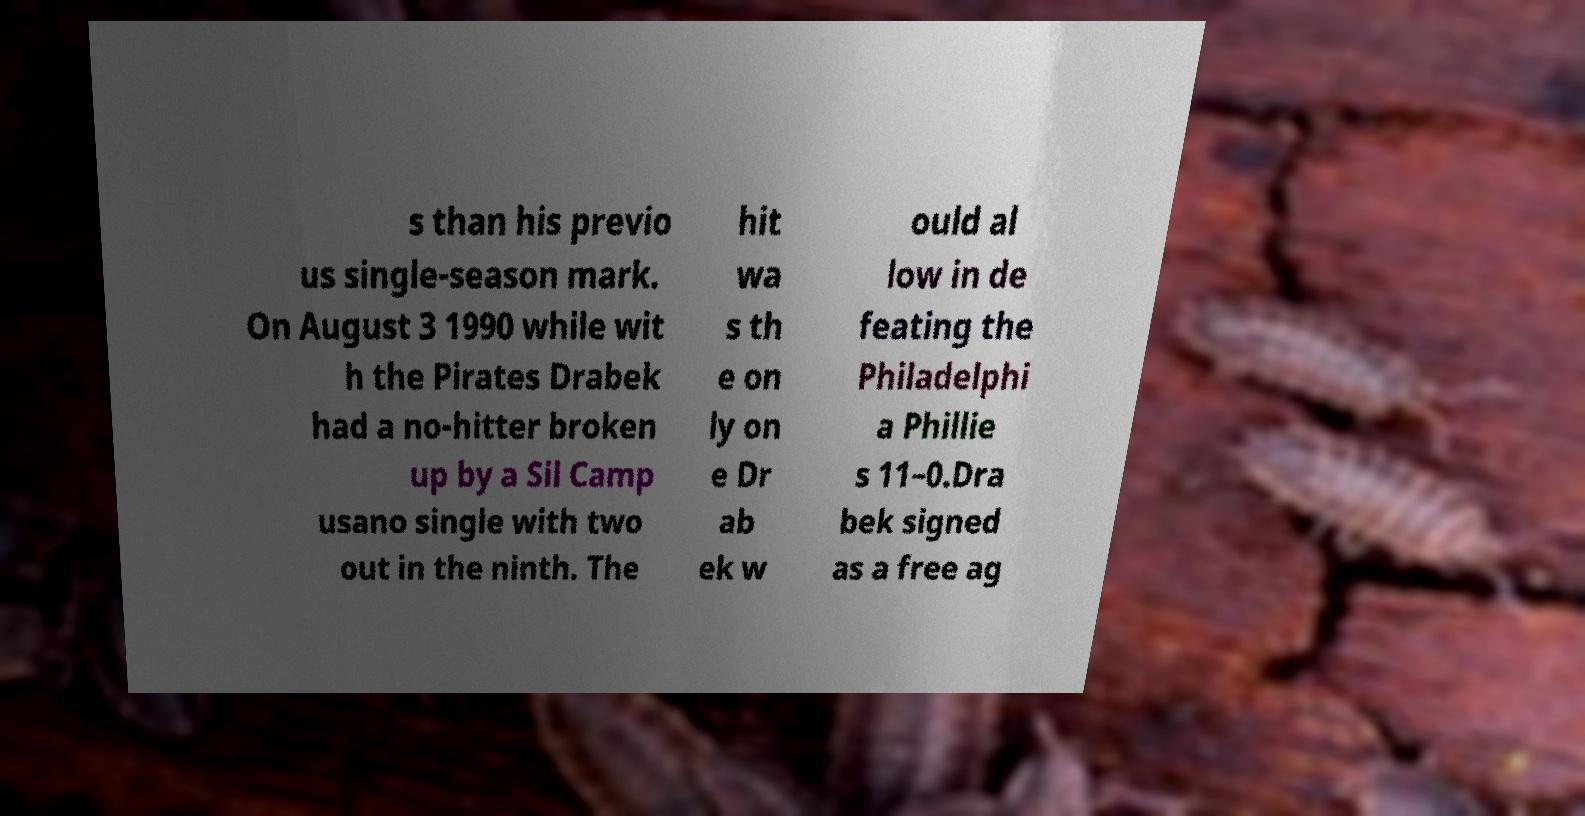For documentation purposes, I need the text within this image transcribed. Could you provide that? s than his previo us single-season mark. On August 3 1990 while wit h the Pirates Drabek had a no-hitter broken up by a Sil Camp usano single with two out in the ninth. The hit wa s th e on ly on e Dr ab ek w ould al low in de feating the Philadelphi a Phillie s 11–0.Dra bek signed as a free ag 